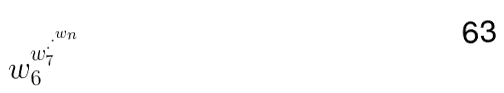Convert formula to latex. <formula><loc_0><loc_0><loc_500><loc_500>w _ { 6 } ^ { w _ { 7 } ^ { \cdot ^ { \cdot ^ { w _ { n } } } } }</formula> 